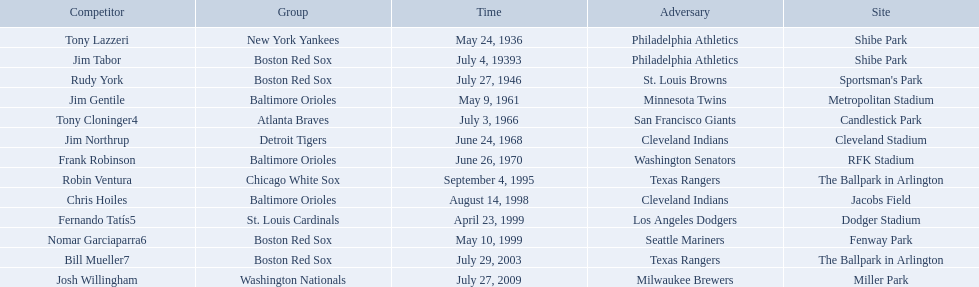What venue did detroit play cleveland in? Cleveland Stadium. Who was the player? Jim Northrup. What date did they play? June 24, 1968. Who are the opponents of the boston red sox during baseball home run records? Philadelphia Athletics, St. Louis Browns, Seattle Mariners, Texas Rangers. Of those which was the opponent on july 27, 1946? St. Louis Browns. Who were all of the players? Tony Lazzeri, Jim Tabor, Rudy York, Jim Gentile, Tony Cloninger4, Jim Northrup, Frank Robinson, Robin Ventura, Chris Hoiles, Fernando Tatís5, Nomar Garciaparra6, Bill Mueller7, Josh Willingham. What year was there a player for the yankees? May 24, 1936. What was the name of that 1936 yankees player? Tony Lazzeri. 